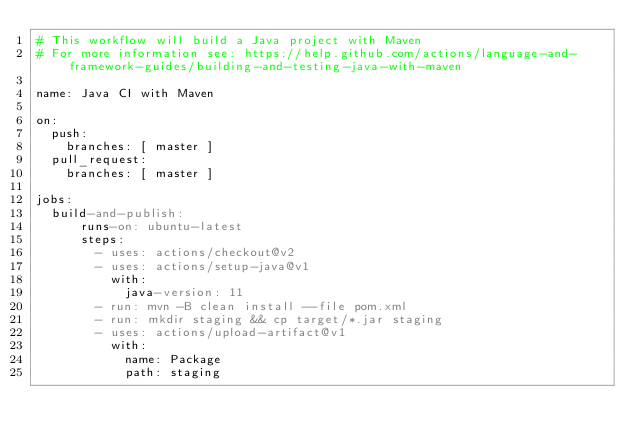<code> <loc_0><loc_0><loc_500><loc_500><_YAML_># This workflow will build a Java project with Maven
# For more information see: https://help.github.com/actions/language-and-framework-guides/building-and-testing-java-with-maven

name: Java CI with Maven

on:
  push:
    branches: [ master ]
  pull_request:
    branches: [ master ]

jobs:
  build-and-publish:
      runs-on: ubuntu-latest
      steps:
        - uses: actions/checkout@v2
        - uses: actions/setup-java@v1
          with:
            java-version: 11
        - run: mvn -B clean install --file pom.xml
        - run: mkdir staging && cp target/*.jar staging
        - uses: actions/upload-artifact@v1
          with:
            name: Package
            path: staging
</code> 